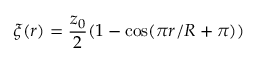<formula> <loc_0><loc_0><loc_500><loc_500>\xi ( r ) = \frac { z _ { 0 } } { 2 } ( 1 - \cos ( \pi r / R + \pi ) )</formula> 